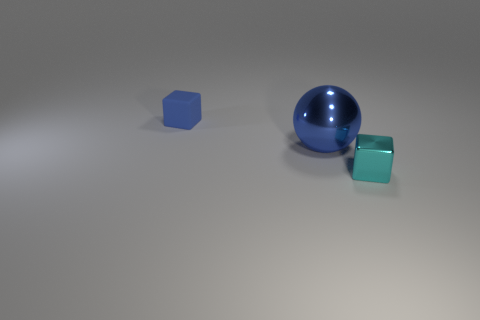Add 2 shiny objects. How many objects exist? 5 Subtract all cubes. How many objects are left? 1 Subtract all yellow balls. Subtract all red cylinders. How many balls are left? 1 Subtract all blue cylinders. How many brown blocks are left? 0 Subtract all tiny gray objects. Subtract all shiny spheres. How many objects are left? 2 Add 3 small blue objects. How many small blue objects are left? 4 Add 3 big gray matte cylinders. How many big gray matte cylinders exist? 3 Subtract 1 blue spheres. How many objects are left? 2 Subtract 1 blocks. How many blocks are left? 1 